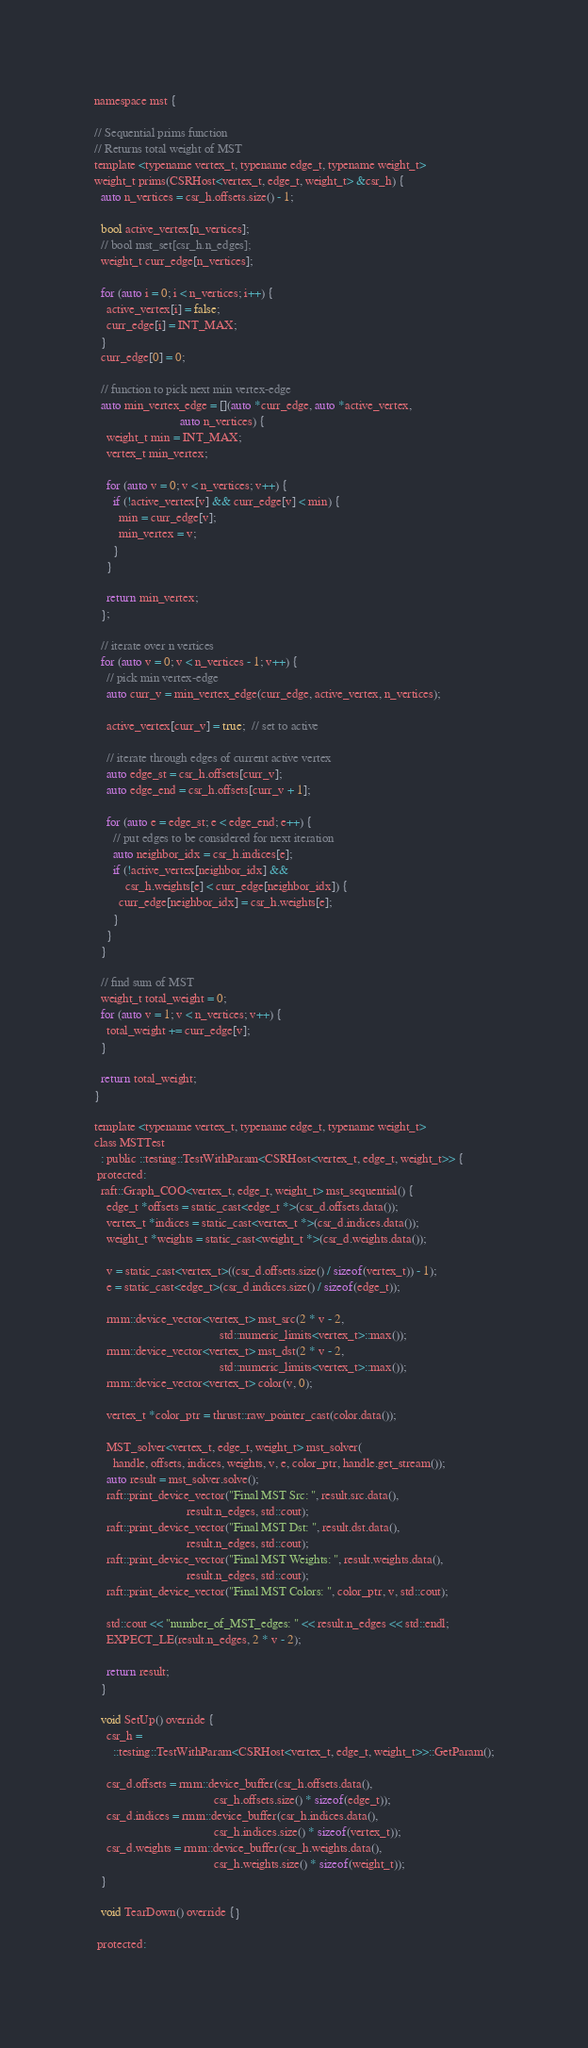Convert code to text. <code><loc_0><loc_0><loc_500><loc_500><_Cuda_>namespace mst {

// Sequential prims function
// Returns total weight of MST
template <typename vertex_t, typename edge_t, typename weight_t>
weight_t prims(CSRHost<vertex_t, edge_t, weight_t> &csr_h) {
  auto n_vertices = csr_h.offsets.size() - 1;

  bool active_vertex[n_vertices];
  // bool mst_set[csr_h.n_edges];
  weight_t curr_edge[n_vertices];

  for (auto i = 0; i < n_vertices; i++) {
    active_vertex[i] = false;
    curr_edge[i] = INT_MAX;
  }
  curr_edge[0] = 0;

  // function to pick next min vertex-edge
  auto min_vertex_edge = [](auto *curr_edge, auto *active_vertex,
                            auto n_vertices) {
    weight_t min = INT_MAX;
    vertex_t min_vertex;

    for (auto v = 0; v < n_vertices; v++) {
      if (!active_vertex[v] && curr_edge[v] < min) {
        min = curr_edge[v];
        min_vertex = v;
      }
    }

    return min_vertex;
  };

  // iterate over n vertices
  for (auto v = 0; v < n_vertices - 1; v++) {
    // pick min vertex-edge
    auto curr_v = min_vertex_edge(curr_edge, active_vertex, n_vertices);

    active_vertex[curr_v] = true;  // set to active

    // iterate through edges of current active vertex
    auto edge_st = csr_h.offsets[curr_v];
    auto edge_end = csr_h.offsets[curr_v + 1];

    for (auto e = edge_st; e < edge_end; e++) {
      // put edges to be considered for next iteration
      auto neighbor_idx = csr_h.indices[e];
      if (!active_vertex[neighbor_idx] &&
          csr_h.weights[e] < curr_edge[neighbor_idx]) {
        curr_edge[neighbor_idx] = csr_h.weights[e];
      }
    }
  }

  // find sum of MST
  weight_t total_weight = 0;
  for (auto v = 1; v < n_vertices; v++) {
    total_weight += curr_edge[v];
  }

  return total_weight;
}

template <typename vertex_t, typename edge_t, typename weight_t>
class MSTTest
  : public ::testing::TestWithParam<CSRHost<vertex_t, edge_t, weight_t>> {
 protected:
  raft::Graph_COO<vertex_t, edge_t, weight_t> mst_sequential() {
    edge_t *offsets = static_cast<edge_t *>(csr_d.offsets.data());
    vertex_t *indices = static_cast<vertex_t *>(csr_d.indices.data());
    weight_t *weights = static_cast<weight_t *>(csr_d.weights.data());

    v = static_cast<vertex_t>((csr_d.offsets.size() / sizeof(vertex_t)) - 1);
    e = static_cast<edge_t>(csr_d.indices.size() / sizeof(edge_t));

    rmm::device_vector<vertex_t> mst_src(2 * v - 2,
                                         std::numeric_limits<vertex_t>::max());
    rmm::device_vector<vertex_t> mst_dst(2 * v - 2,
                                         std::numeric_limits<vertex_t>::max());
    rmm::device_vector<vertex_t> color(v, 0);

    vertex_t *color_ptr = thrust::raw_pointer_cast(color.data());

    MST_solver<vertex_t, edge_t, weight_t> mst_solver(
      handle, offsets, indices, weights, v, e, color_ptr, handle.get_stream());
    auto result = mst_solver.solve();
    raft::print_device_vector("Final MST Src: ", result.src.data(),
                              result.n_edges, std::cout);
    raft::print_device_vector("Final MST Dst: ", result.dst.data(),
                              result.n_edges, std::cout);
    raft::print_device_vector("Final MST Weights: ", result.weights.data(),
                              result.n_edges, std::cout);
    raft::print_device_vector("Final MST Colors: ", color_ptr, v, std::cout);

    std::cout << "number_of_MST_edges: " << result.n_edges << std::endl;
    EXPECT_LE(result.n_edges, 2 * v - 2);

    return result;
  }

  void SetUp() override {
    csr_h =
      ::testing::TestWithParam<CSRHost<vertex_t, edge_t, weight_t>>::GetParam();

    csr_d.offsets = rmm::device_buffer(csr_h.offsets.data(),
                                       csr_h.offsets.size() * sizeof(edge_t));
    csr_d.indices = rmm::device_buffer(csr_h.indices.data(),
                                       csr_h.indices.size() * sizeof(vertex_t));
    csr_d.weights = rmm::device_buffer(csr_h.weights.data(),
                                       csr_h.weights.size() * sizeof(weight_t));
  }

  void TearDown() override {}

 protected:</code> 